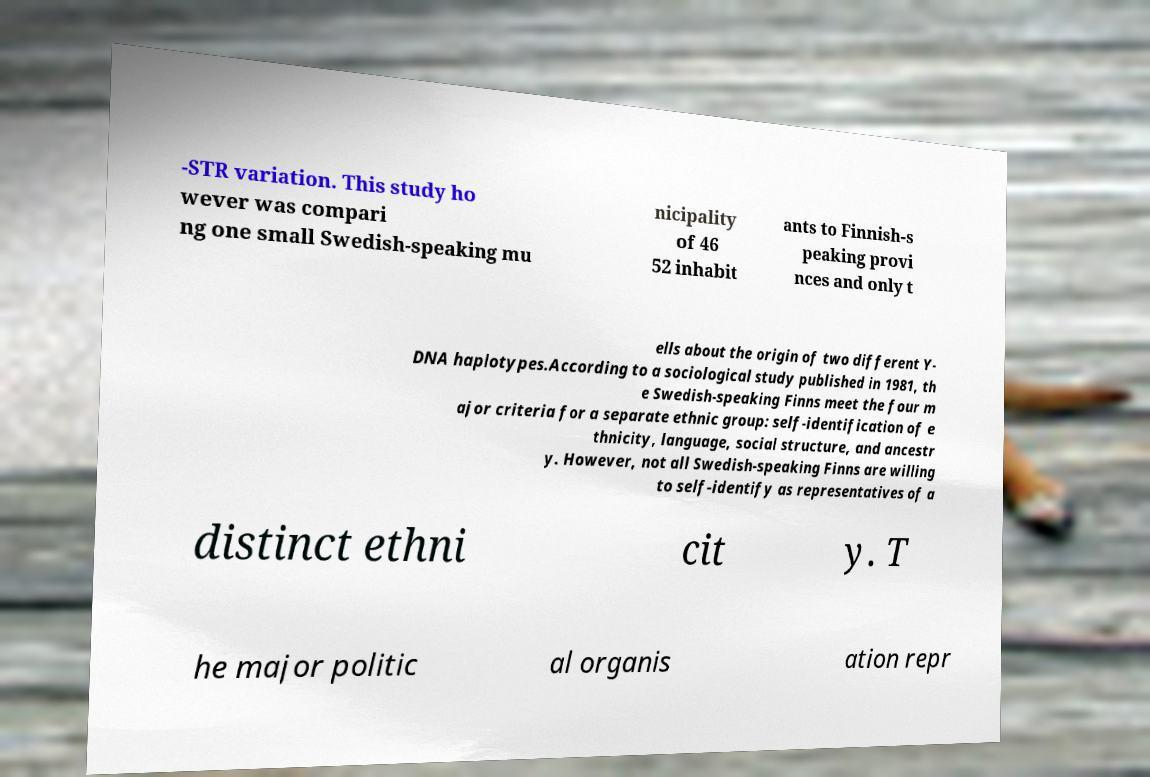There's text embedded in this image that I need extracted. Can you transcribe it verbatim? -STR variation. This study ho wever was compari ng one small Swedish-speaking mu nicipality of 46 52 inhabit ants to Finnish-s peaking provi nces and only t ells about the origin of two different Y- DNA haplotypes.According to a sociological study published in 1981, th e Swedish-speaking Finns meet the four m ajor criteria for a separate ethnic group: self-identification of e thnicity, language, social structure, and ancestr y. However, not all Swedish-speaking Finns are willing to self-identify as representatives of a distinct ethni cit y. T he major politic al organis ation repr 